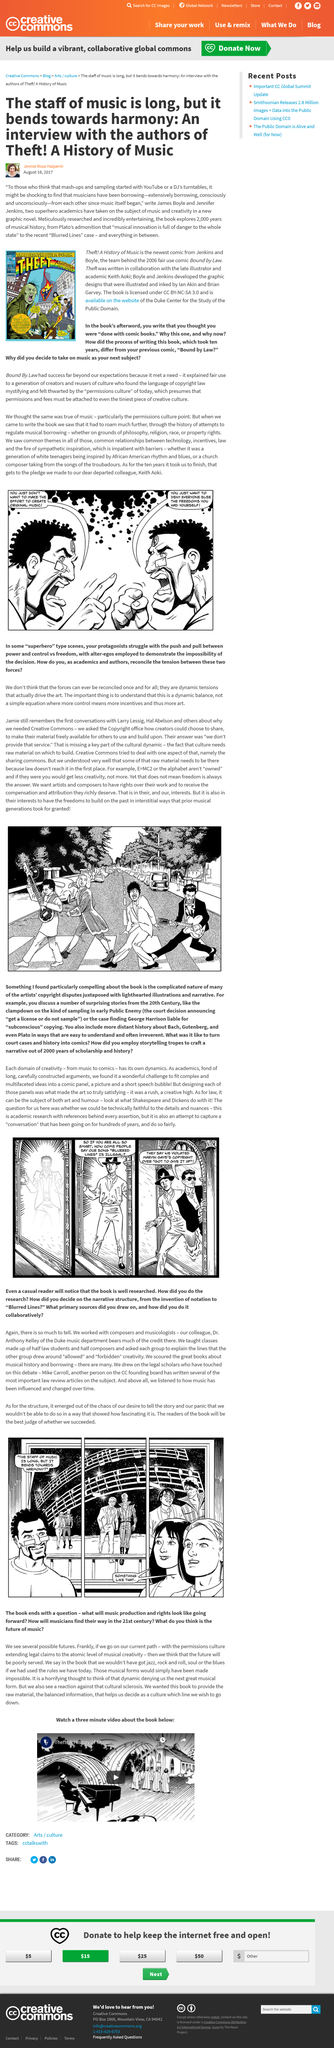List a handful of essential elements in this visual. Keith Aoki is the illustrator of "Theft! A History of Music". The writer of the article is Jennie Rose Halperin. The book titled Theft! A History of Music, written by Jenkins and Boyle, was authored by two individuals. 